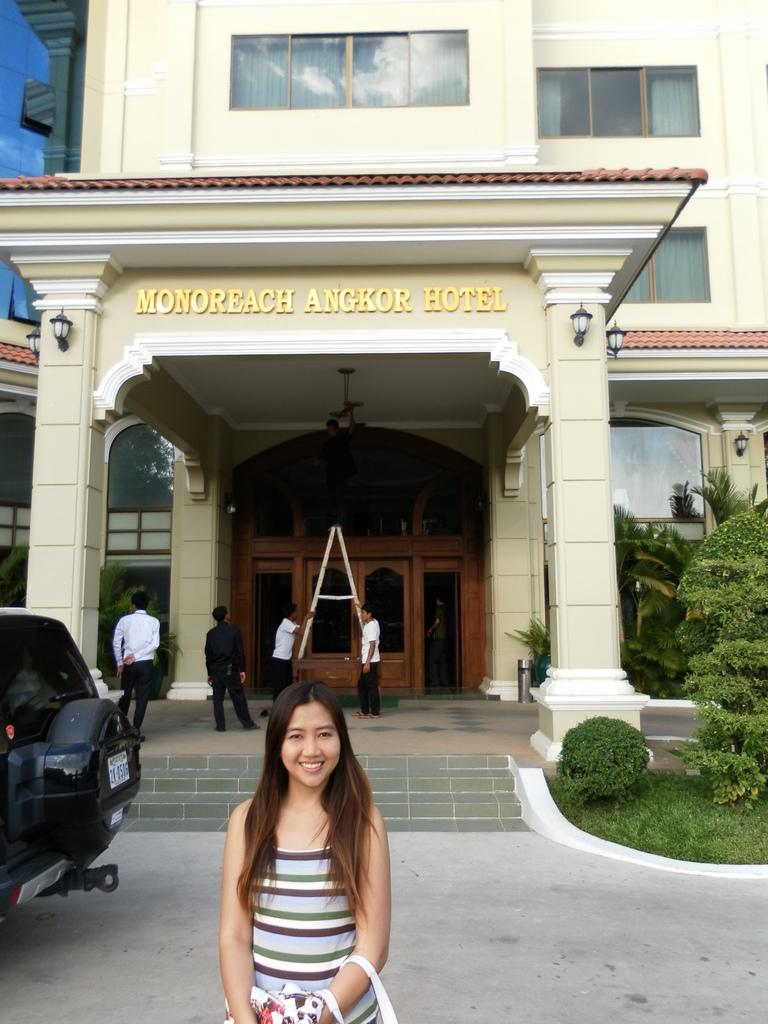Describe this image in one or two sentences. In this image in the center there are buildings and there are some people standing, and there is a ladder. At the bottom there is one woman standing and smiling, and on the right side of the image there are some plants and grass and also we could see pillars, lights and on the building there is text. On the left side there is a vehicle, at the bottom there is a walkway. 